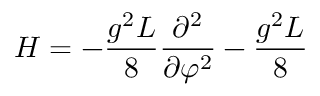<formula> <loc_0><loc_0><loc_500><loc_500>H = - \frac { g ^ { 2 } L } { 8 } \frac { \partial ^ { 2 } } { \partial \varphi ^ { 2 } } - \frac { g ^ { 2 } L } { 8 }</formula> 